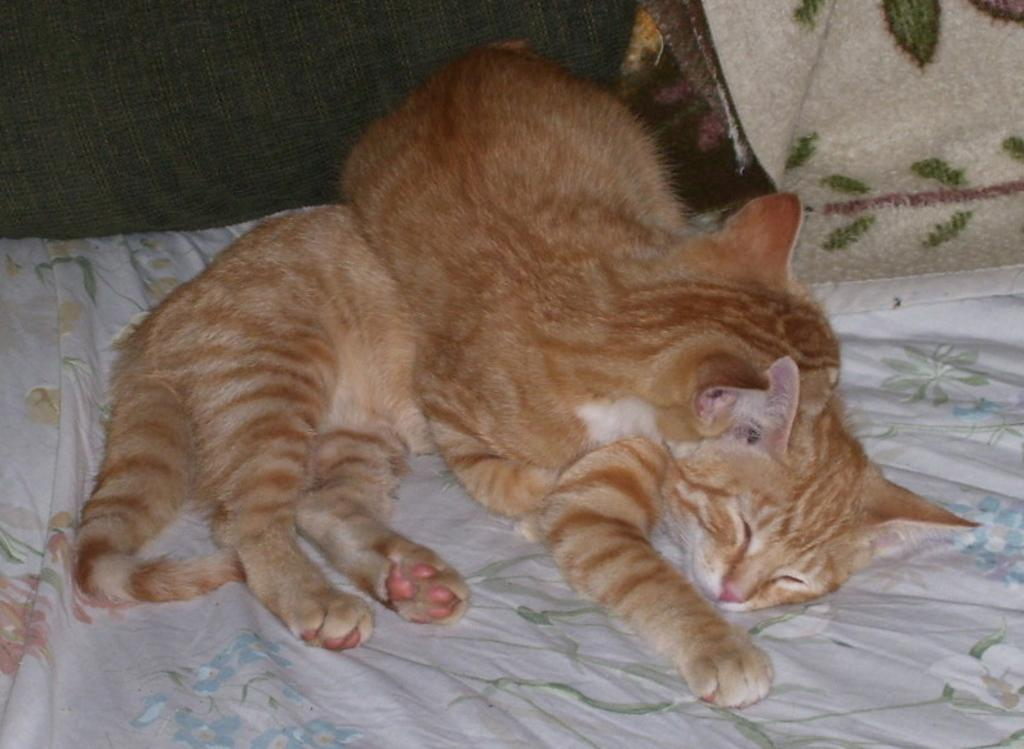How many cats are in the picture? There are two cats in the picture. Where are the cats located in the image? The cats are on the bed. What can be seen on the bed sheet? There are designs on the bed sheet. What type of statement can be seen on the zebra in the image? There is no zebra present in the image, and therefore no statement can be seen on it. 